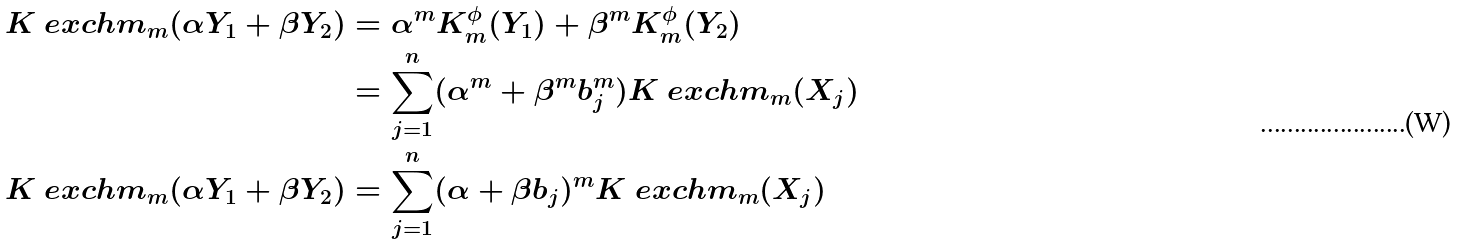<formula> <loc_0><loc_0><loc_500><loc_500>K ^ { \ } e x c h m _ { m } ( \alpha Y _ { 1 } + \beta Y _ { 2 } ) & = \alpha ^ { m } K ^ { \phi } _ { m } ( Y _ { 1 } ) + \beta ^ { m } K ^ { \phi } _ { m } ( Y _ { 2 } ) \\ & = \sum _ { j = 1 } ^ { n } ( \alpha ^ { m } + \beta ^ { m } b _ { j } ^ { m } ) K ^ { \ } e x c h m _ { m } ( X _ { j } ) \\ K ^ { \ } e x c h m _ { m } ( \alpha Y _ { 1 } + \beta Y _ { 2 } ) & = \sum _ { j = 1 } ^ { n } ( \alpha + \beta b _ { j } ) ^ { m } K ^ { \ } e x c h m _ { m } ( X _ { j } ) \\</formula> 